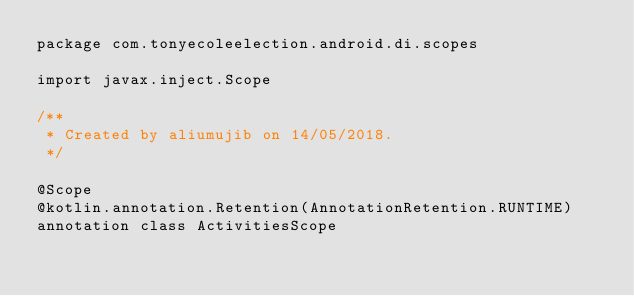Convert code to text. <code><loc_0><loc_0><loc_500><loc_500><_Kotlin_>package com.tonyecoleelection.android.di.scopes

import javax.inject.Scope

/**
 * Created by aliumujib on 14/05/2018.
 */

@Scope
@kotlin.annotation.Retention(AnnotationRetention.RUNTIME)
annotation class ActivitiesScope</code> 